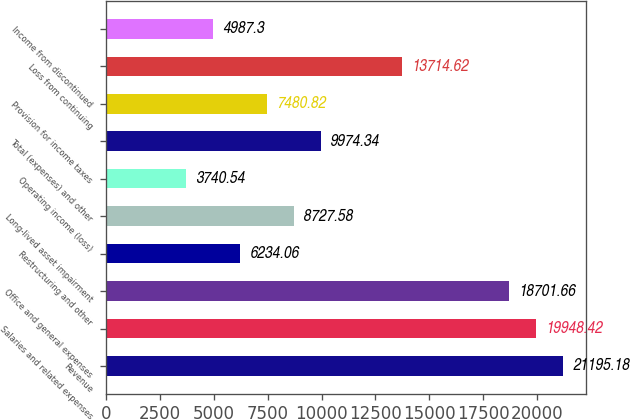Convert chart. <chart><loc_0><loc_0><loc_500><loc_500><bar_chart><fcel>Revenue<fcel>Salaries and related expenses<fcel>Office and general expenses<fcel>Restructuring and other<fcel>Long-lived asset impairment<fcel>Operating income (loss)<fcel>Total (expenses) and other<fcel>Provision for income taxes<fcel>Loss from continuing<fcel>Income from discontinued<nl><fcel>21195.2<fcel>19948.4<fcel>18701.7<fcel>6234.06<fcel>8727.58<fcel>3740.54<fcel>9974.34<fcel>7480.82<fcel>13714.6<fcel>4987.3<nl></chart> 